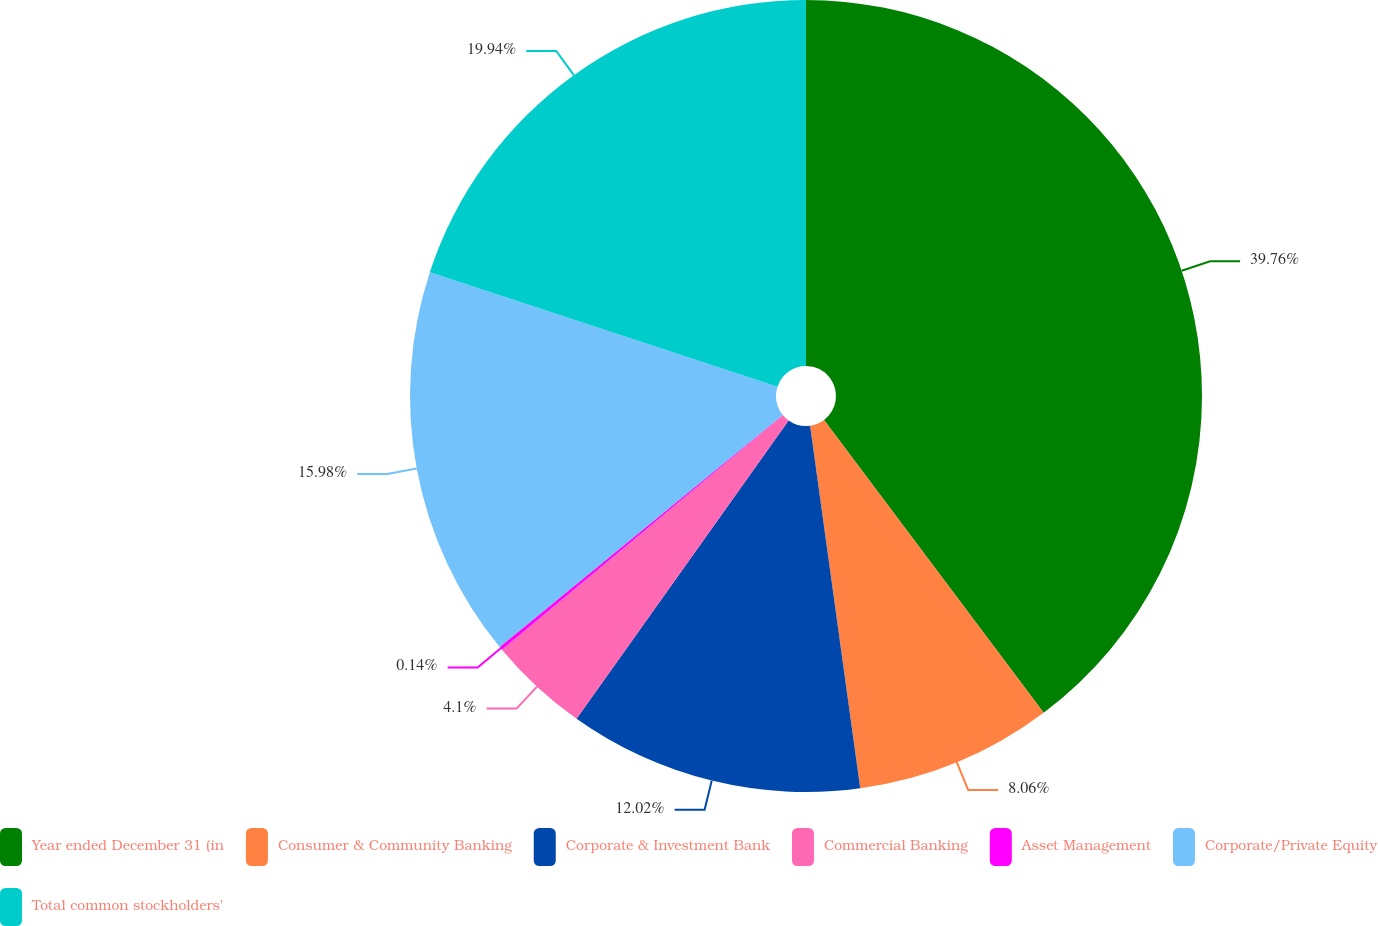Convert chart to OTSL. <chart><loc_0><loc_0><loc_500><loc_500><pie_chart><fcel>Year ended December 31 (in<fcel>Consumer & Community Banking<fcel>Corporate & Investment Bank<fcel>Commercial Banking<fcel>Asset Management<fcel>Corporate/Private Equity<fcel>Total common stockholders'<nl><fcel>39.75%<fcel>8.06%<fcel>12.02%<fcel>4.1%<fcel>0.14%<fcel>15.98%<fcel>19.94%<nl></chart> 